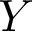Convert formula to latex. <formula><loc_0><loc_0><loc_500><loc_500>Y</formula> 